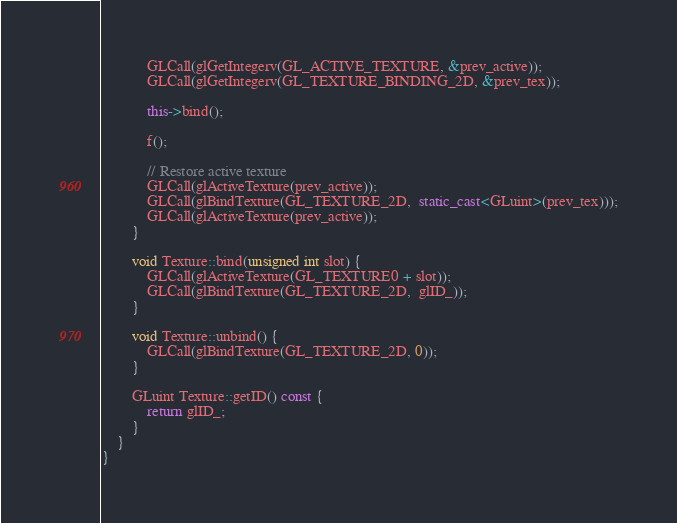Convert code to text. <code><loc_0><loc_0><loc_500><loc_500><_C++_>            GLCall(glGetIntegerv(GL_ACTIVE_TEXTURE, &prev_active));
            GLCall(glGetIntegerv(GL_TEXTURE_BINDING_2D, &prev_tex));

            this->bind();

            f();

            // Restore active texture
            GLCall(glActiveTexture(prev_active));
            GLCall(glBindTexture(GL_TEXTURE_2D,  static_cast<GLuint>(prev_tex)));
            GLCall(glActiveTexture(prev_active));
        }

        void Texture::bind(unsigned int slot) {
            GLCall(glActiveTexture(GL_TEXTURE0 + slot));
            GLCall(glBindTexture(GL_TEXTURE_2D,  glID_));
        }

        void Texture::unbind() {
            GLCall(glBindTexture(GL_TEXTURE_2D, 0));
        }

        GLuint Texture::getID() const {
            return glID_;
        }
    }
}
</code> 